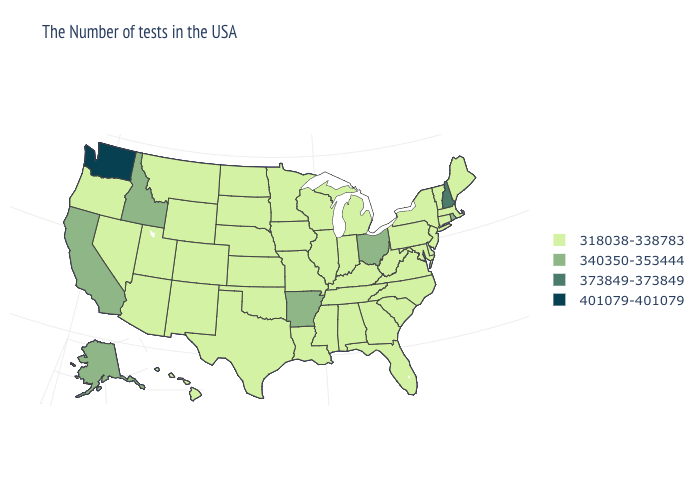Which states have the highest value in the USA?
Answer briefly. Washington. What is the value of Wyoming?
Give a very brief answer. 318038-338783. Name the states that have a value in the range 401079-401079?
Keep it brief. Washington. Does Washington have the highest value in the West?
Write a very short answer. Yes. Does the first symbol in the legend represent the smallest category?
Write a very short answer. Yes. What is the value of Pennsylvania?
Concise answer only. 318038-338783. What is the lowest value in states that border Utah?
Give a very brief answer. 318038-338783. What is the value of South Carolina?
Short answer required. 318038-338783. Among the states that border Iowa , which have the highest value?
Answer briefly. Wisconsin, Illinois, Missouri, Minnesota, Nebraska, South Dakota. What is the highest value in states that border North Carolina?
Write a very short answer. 318038-338783. How many symbols are there in the legend?
Quick response, please. 4. What is the highest value in the USA?
Write a very short answer. 401079-401079. What is the value of Maryland?
Answer briefly. 318038-338783. Name the states that have a value in the range 373849-373849?
Keep it brief. New Hampshire. What is the lowest value in the MidWest?
Give a very brief answer. 318038-338783. 